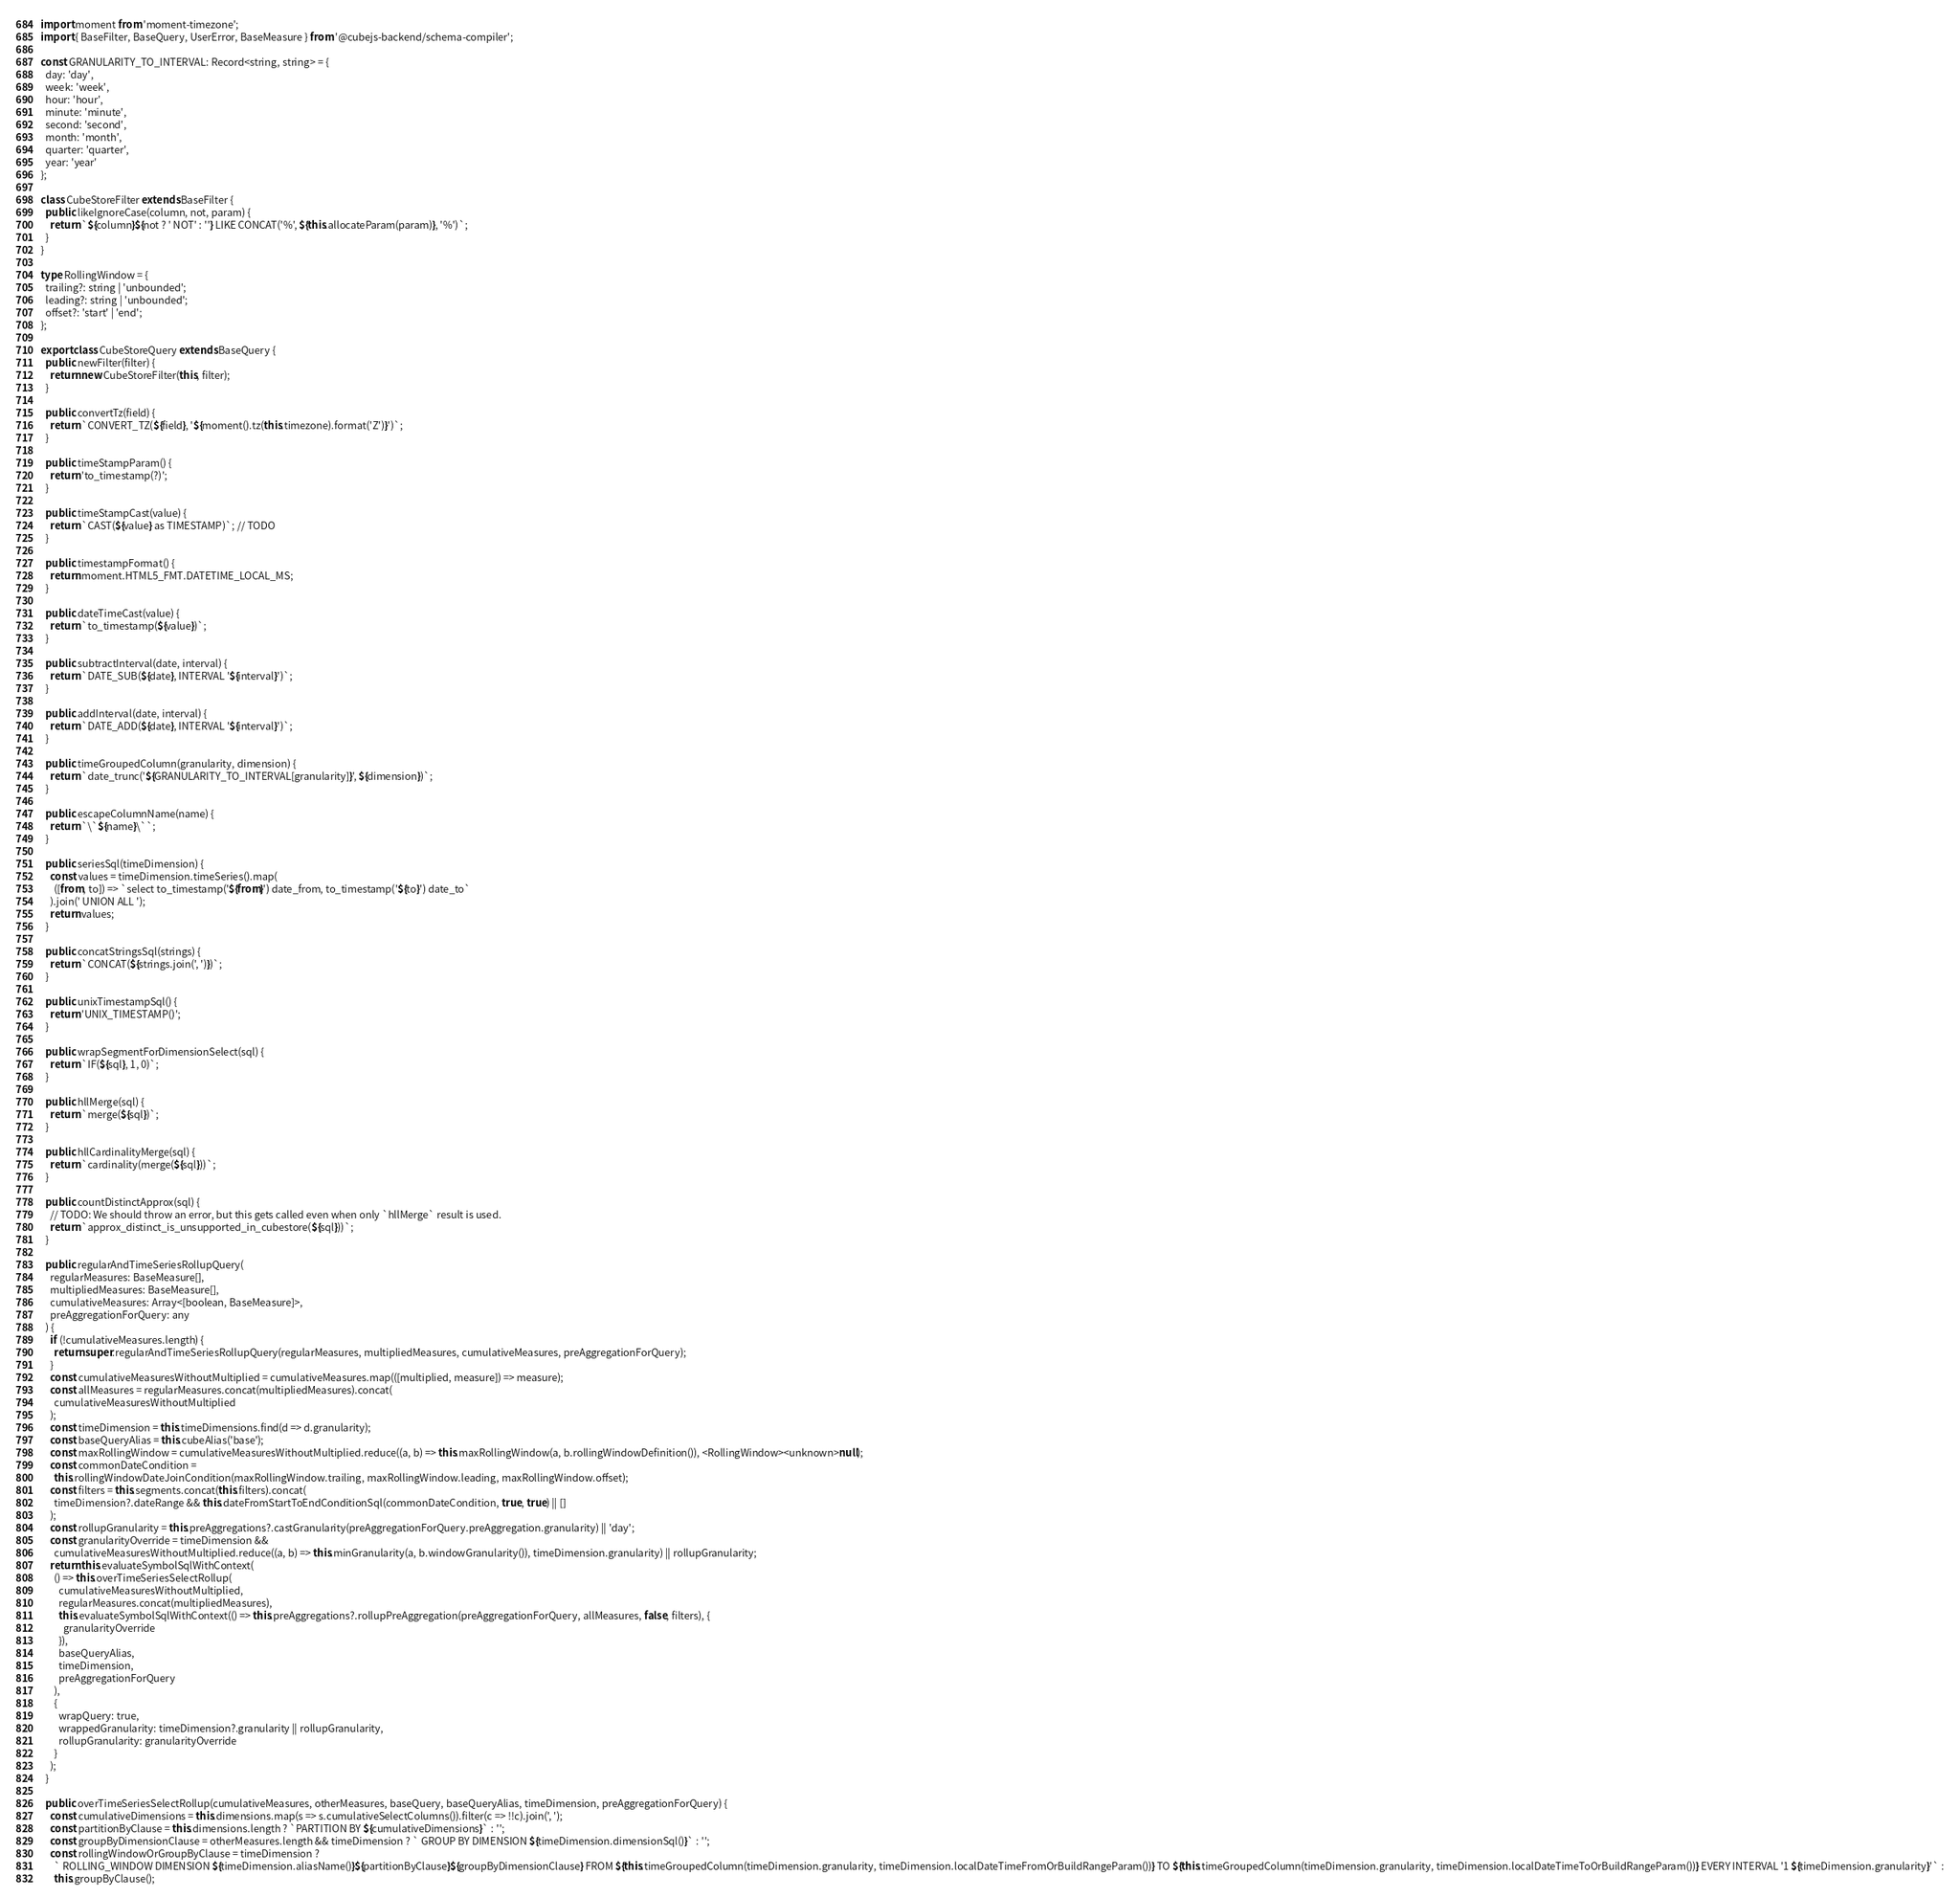Convert code to text. <code><loc_0><loc_0><loc_500><loc_500><_TypeScript_>import moment from 'moment-timezone';
import { BaseFilter, BaseQuery, UserError, BaseMeasure } from '@cubejs-backend/schema-compiler';

const GRANULARITY_TO_INTERVAL: Record<string, string> = {
  day: 'day',
  week: 'week',
  hour: 'hour',
  minute: 'minute',
  second: 'second',
  month: 'month',
  quarter: 'quarter',
  year: 'year'
};

class CubeStoreFilter extends BaseFilter {
  public likeIgnoreCase(column, not, param) {
    return `${column}${not ? ' NOT' : ''} LIKE CONCAT('%', ${this.allocateParam(param)}, '%')`;
  }
}

type RollingWindow = {
  trailing?: string | 'unbounded';
  leading?: string | 'unbounded';
  offset?: 'start' | 'end';
};

export class CubeStoreQuery extends BaseQuery {
  public newFilter(filter) {
    return new CubeStoreFilter(this, filter);
  }

  public convertTz(field) {
    return `CONVERT_TZ(${field}, '${moment().tz(this.timezone).format('Z')}')`;
  }

  public timeStampParam() {
    return 'to_timestamp(?)';
  }

  public timeStampCast(value) {
    return `CAST(${value} as TIMESTAMP)`; // TODO
  }

  public timestampFormat() {
    return moment.HTML5_FMT.DATETIME_LOCAL_MS;
  }

  public dateTimeCast(value) {
    return `to_timestamp(${value})`;
  }

  public subtractInterval(date, interval) {
    return `DATE_SUB(${date}, INTERVAL '${interval}')`;
  }

  public addInterval(date, interval) {
    return `DATE_ADD(${date}, INTERVAL '${interval}')`;
  }

  public timeGroupedColumn(granularity, dimension) {
    return `date_trunc('${GRANULARITY_TO_INTERVAL[granularity]}', ${dimension})`;
  }

  public escapeColumnName(name) {
    return `\`${name}\``;
  }

  public seriesSql(timeDimension) {
    const values = timeDimension.timeSeries().map(
      ([from, to]) => `select to_timestamp('${from}') date_from, to_timestamp('${to}') date_to`
    ).join(' UNION ALL ');
    return values;
  }

  public concatStringsSql(strings) {
    return `CONCAT(${strings.join(', ')})`;
  }

  public unixTimestampSql() {
    return 'UNIX_TIMESTAMP()';
  }

  public wrapSegmentForDimensionSelect(sql) {
    return `IF(${sql}, 1, 0)`;
  }

  public hllMerge(sql) {
    return `merge(${sql})`;
  }

  public hllCardinalityMerge(sql) {
    return `cardinality(merge(${sql}))`;
  }

  public countDistinctApprox(sql) {
    // TODO: We should throw an error, but this gets called even when only `hllMerge` result is used.
    return `approx_distinct_is_unsupported_in_cubestore(${sql}))`;
  }

  public regularAndTimeSeriesRollupQuery(
    regularMeasures: BaseMeasure[],
    multipliedMeasures: BaseMeasure[],
    cumulativeMeasures: Array<[boolean, BaseMeasure]>,
    preAggregationForQuery: any
  ) {
    if (!cumulativeMeasures.length) {
      return super.regularAndTimeSeriesRollupQuery(regularMeasures, multipliedMeasures, cumulativeMeasures, preAggregationForQuery);
    }
    const cumulativeMeasuresWithoutMultiplied = cumulativeMeasures.map(([multiplied, measure]) => measure);
    const allMeasures = regularMeasures.concat(multipliedMeasures).concat(
      cumulativeMeasuresWithoutMultiplied
    );
    const timeDimension = this.timeDimensions.find(d => d.granularity);
    const baseQueryAlias = this.cubeAlias('base');
    const maxRollingWindow = cumulativeMeasuresWithoutMultiplied.reduce((a, b) => this.maxRollingWindow(a, b.rollingWindowDefinition()), <RollingWindow><unknown>null);
    const commonDateCondition =
      this.rollingWindowDateJoinCondition(maxRollingWindow.trailing, maxRollingWindow.leading, maxRollingWindow.offset);
    const filters = this.segments.concat(this.filters).concat(
      timeDimension?.dateRange && this.dateFromStartToEndConditionSql(commonDateCondition, true, true) || []
    );
    const rollupGranularity = this.preAggregations?.castGranularity(preAggregationForQuery.preAggregation.granularity) || 'day';
    const granularityOverride = timeDimension &&
      cumulativeMeasuresWithoutMultiplied.reduce((a, b) => this.minGranularity(a, b.windowGranularity()), timeDimension.granularity) || rollupGranularity;
    return this.evaluateSymbolSqlWithContext(
      () => this.overTimeSeriesSelectRollup(
        cumulativeMeasuresWithoutMultiplied,
        regularMeasures.concat(multipliedMeasures),
        this.evaluateSymbolSqlWithContext(() => this.preAggregations?.rollupPreAggregation(preAggregationForQuery, allMeasures, false, filters), {
          granularityOverride
        }),
        baseQueryAlias,
        timeDimension,
        preAggregationForQuery
      ),
      {
        wrapQuery: true,
        wrappedGranularity: timeDimension?.granularity || rollupGranularity,
        rollupGranularity: granularityOverride
      }
    );
  }

  public overTimeSeriesSelectRollup(cumulativeMeasures, otherMeasures, baseQuery, baseQueryAlias, timeDimension, preAggregationForQuery) {
    const cumulativeDimensions = this.dimensions.map(s => s.cumulativeSelectColumns()).filter(c => !!c).join(', ');
    const partitionByClause = this.dimensions.length ? `PARTITION BY ${cumulativeDimensions}` : '';
    const groupByDimensionClause = otherMeasures.length && timeDimension ? ` GROUP BY DIMENSION ${timeDimension.dimensionSql()}` : '';
    const rollingWindowOrGroupByClause = timeDimension ?
      ` ROLLING_WINDOW DIMENSION ${timeDimension.aliasName()}${partitionByClause}${groupByDimensionClause} FROM ${this.timeGroupedColumn(timeDimension.granularity, timeDimension.localDateTimeFromOrBuildRangeParam())} TO ${this.timeGroupedColumn(timeDimension.granularity, timeDimension.localDateTimeToOrBuildRangeParam())} EVERY INTERVAL '1 ${timeDimension.granularity}'` :
      this.groupByClause();</code> 